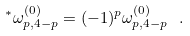<formula> <loc_0><loc_0><loc_500><loc_500>^ { * } \omega ^ { ( 0 ) } _ { p , 4 - p } = ( - 1 ) ^ { p } \omega ^ { ( 0 ) } _ { p , 4 - p } \ .</formula> 